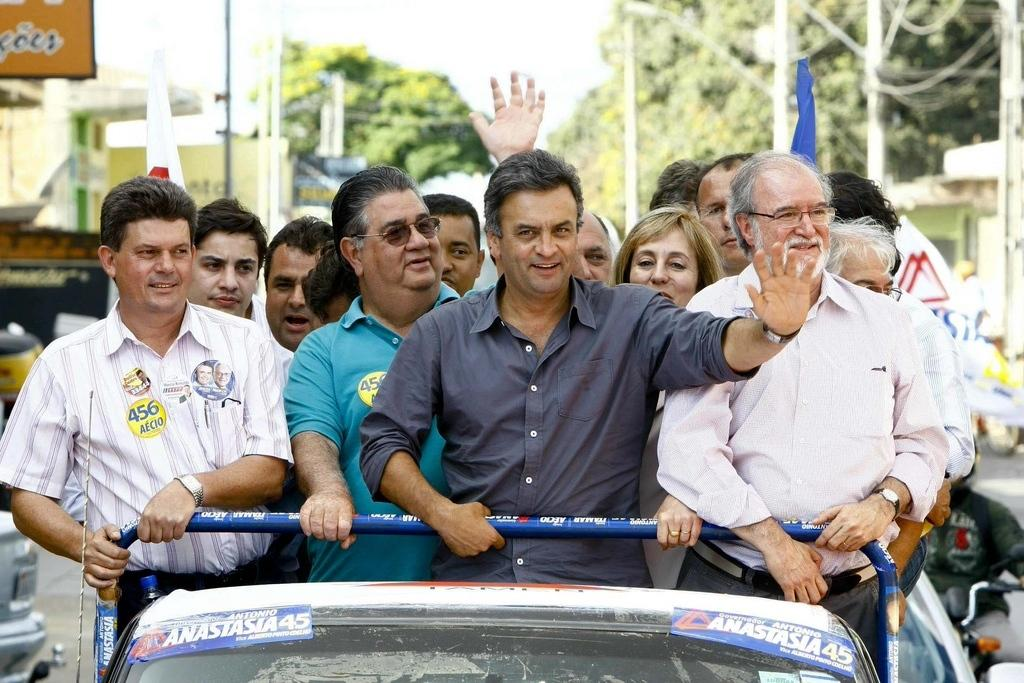What are the people in the image doing? The people in the image are standing on a vehicle. What can be seen on the vehicle besides the people? There are posters on the vehicle. What can be seen in the background of the image? Trees are visible in the background, along with other unspecified elements. How many boys are holding clubs and standing next to bears in the image? There are no boys, clubs, or bears present in the image. 